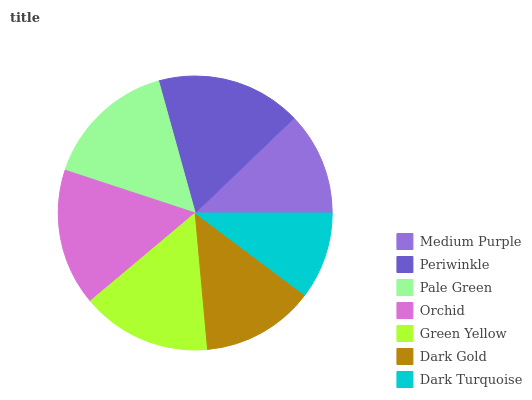Is Dark Turquoise the minimum?
Answer yes or no. Yes. Is Periwinkle the maximum?
Answer yes or no. Yes. Is Pale Green the minimum?
Answer yes or no. No. Is Pale Green the maximum?
Answer yes or no. No. Is Periwinkle greater than Pale Green?
Answer yes or no. Yes. Is Pale Green less than Periwinkle?
Answer yes or no. Yes. Is Pale Green greater than Periwinkle?
Answer yes or no. No. Is Periwinkle less than Pale Green?
Answer yes or no. No. Is Green Yellow the high median?
Answer yes or no. Yes. Is Green Yellow the low median?
Answer yes or no. Yes. Is Orchid the high median?
Answer yes or no. No. Is Dark Gold the low median?
Answer yes or no. No. 